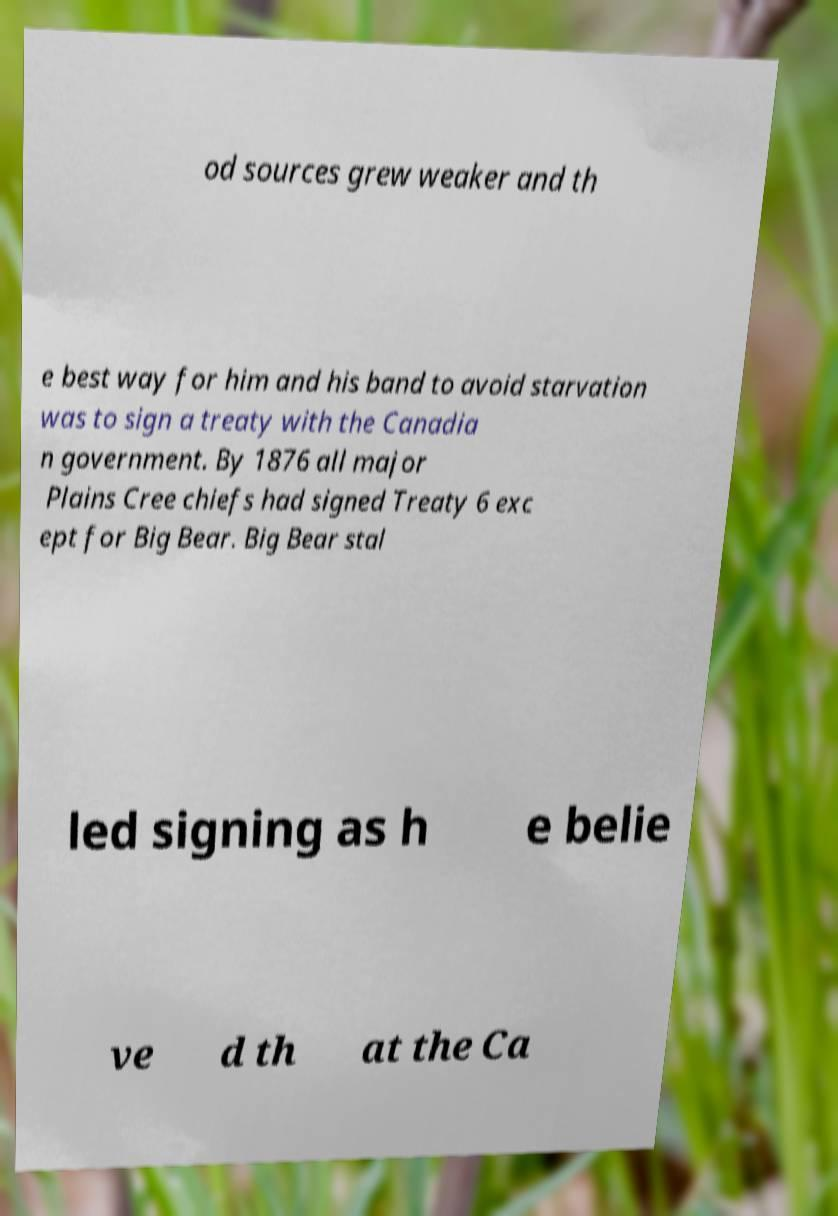Could you assist in decoding the text presented in this image and type it out clearly? od sources grew weaker and th e best way for him and his band to avoid starvation was to sign a treaty with the Canadia n government. By 1876 all major Plains Cree chiefs had signed Treaty 6 exc ept for Big Bear. Big Bear stal led signing as h e belie ve d th at the Ca 